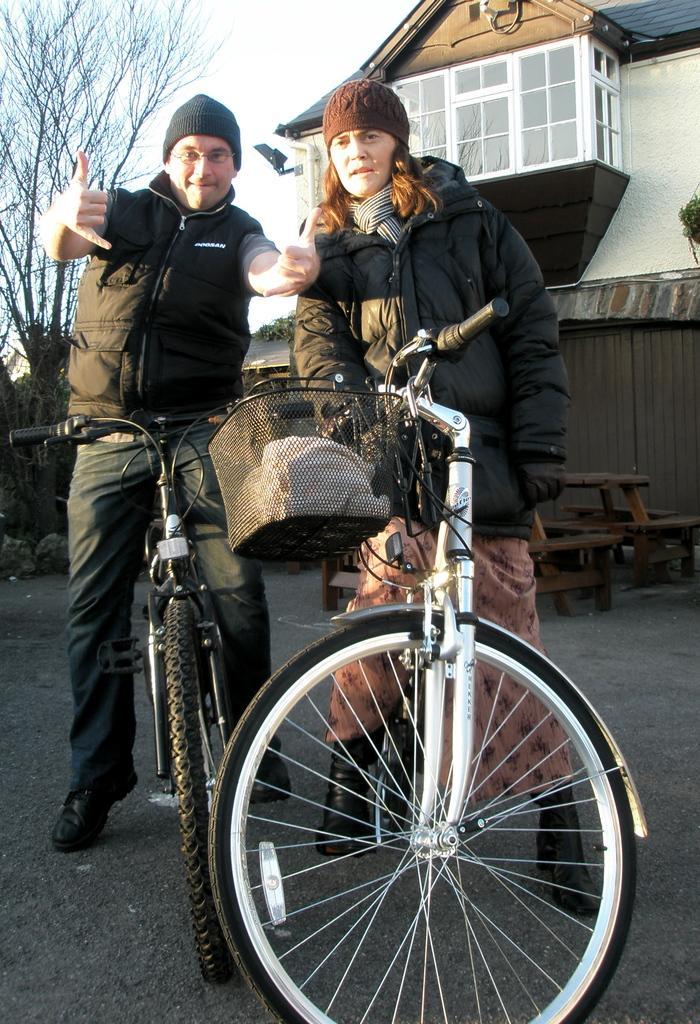Describe this image in one or two sentences. In this image i can see a man and a woman on the bicycles. In the background i can see the sky, a tree and a building. I can see few benches and the fence wall. 